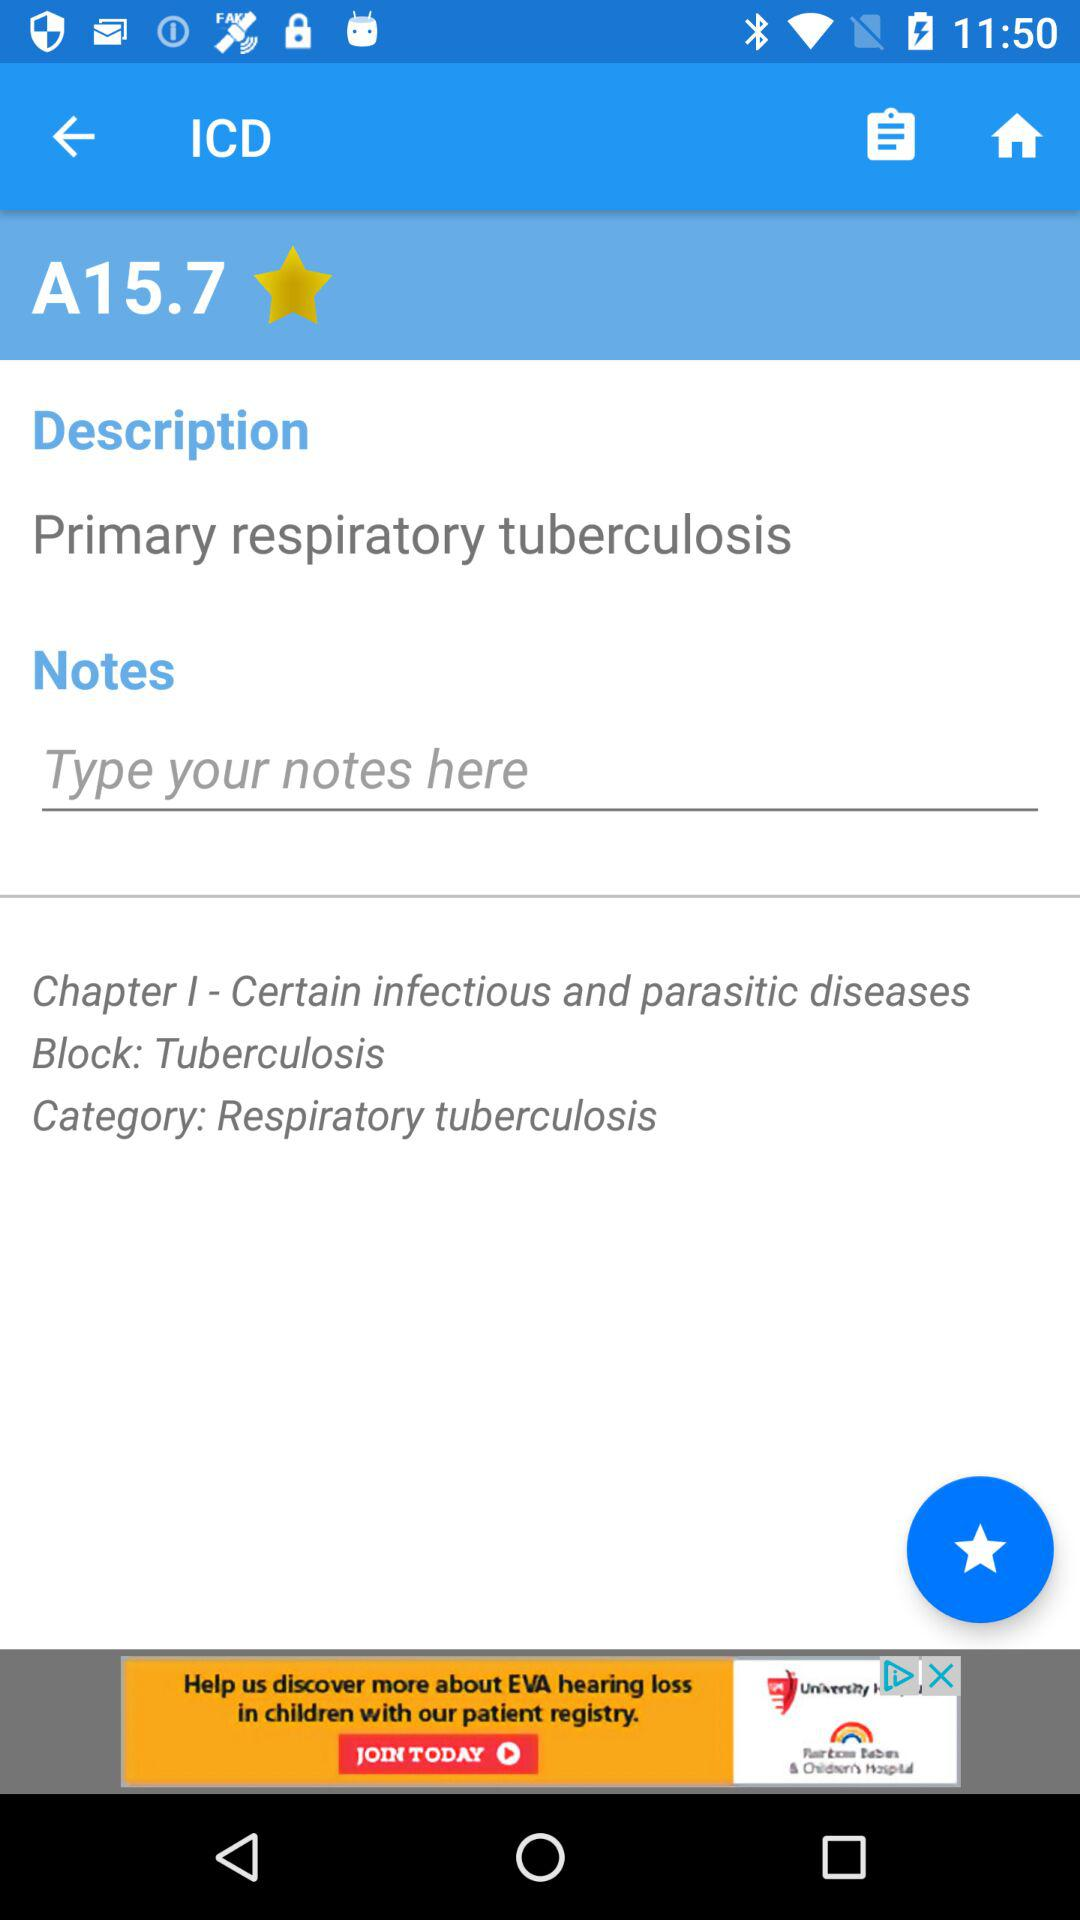What is the block? The block is "Tuberculosis". 